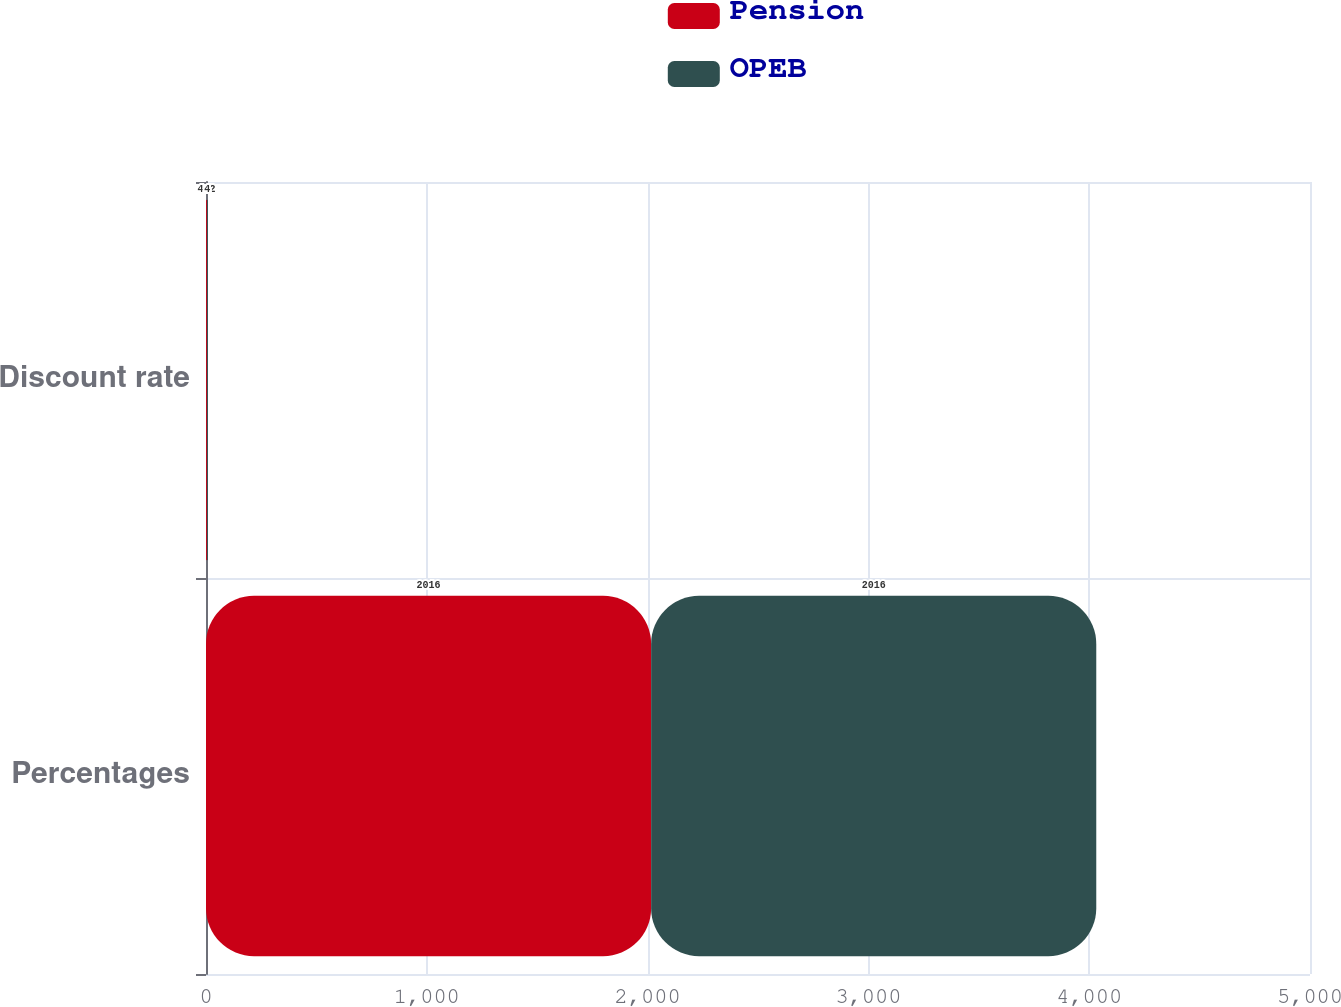Convert chart. <chart><loc_0><loc_0><loc_500><loc_500><stacked_bar_chart><ecel><fcel>Percentages<fcel>Discount rate<nl><fcel>Pension<fcel>2016<fcel>4.2<nl><fcel>OPEB<fcel>2016<fcel>4<nl></chart> 